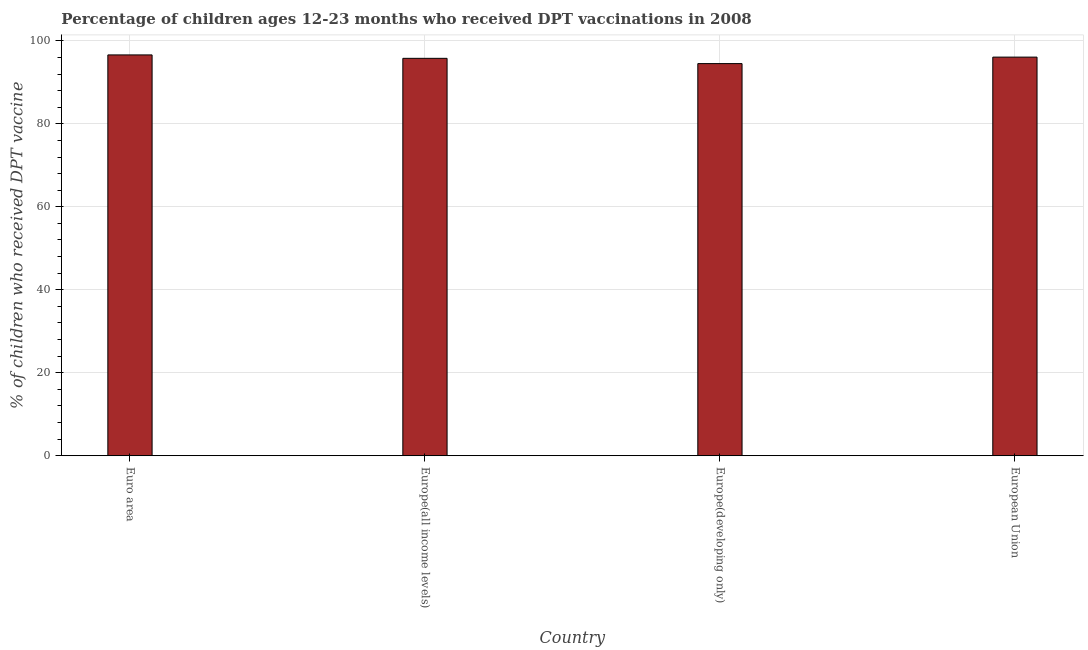Does the graph contain any zero values?
Your answer should be compact. No. What is the title of the graph?
Your response must be concise. Percentage of children ages 12-23 months who received DPT vaccinations in 2008. What is the label or title of the X-axis?
Make the answer very short. Country. What is the label or title of the Y-axis?
Ensure brevity in your answer.  % of children who received DPT vaccine. What is the percentage of children who received dpt vaccine in European Union?
Offer a very short reply. 96.08. Across all countries, what is the maximum percentage of children who received dpt vaccine?
Provide a short and direct response. 96.61. Across all countries, what is the minimum percentage of children who received dpt vaccine?
Keep it short and to the point. 94.52. In which country was the percentage of children who received dpt vaccine minimum?
Provide a short and direct response. Europe(developing only). What is the sum of the percentage of children who received dpt vaccine?
Offer a very short reply. 382.99. What is the difference between the percentage of children who received dpt vaccine in Euro area and Europe(developing only)?
Ensure brevity in your answer.  2.09. What is the average percentage of children who received dpt vaccine per country?
Offer a terse response. 95.75. What is the median percentage of children who received dpt vaccine?
Give a very brief answer. 95.93. What is the difference between the highest and the second highest percentage of children who received dpt vaccine?
Keep it short and to the point. 0.53. What is the difference between the highest and the lowest percentage of children who received dpt vaccine?
Keep it short and to the point. 2.09. What is the % of children who received DPT vaccine of Euro area?
Ensure brevity in your answer.  96.61. What is the % of children who received DPT vaccine in Europe(all income levels)?
Your response must be concise. 95.78. What is the % of children who received DPT vaccine in Europe(developing only)?
Offer a terse response. 94.52. What is the % of children who received DPT vaccine of European Union?
Ensure brevity in your answer.  96.08. What is the difference between the % of children who received DPT vaccine in Euro area and Europe(all income levels)?
Give a very brief answer. 0.82. What is the difference between the % of children who received DPT vaccine in Euro area and Europe(developing only)?
Give a very brief answer. 2.09. What is the difference between the % of children who received DPT vaccine in Euro area and European Union?
Provide a short and direct response. 0.53. What is the difference between the % of children who received DPT vaccine in Europe(all income levels) and Europe(developing only)?
Ensure brevity in your answer.  1.27. What is the difference between the % of children who received DPT vaccine in Europe(all income levels) and European Union?
Your answer should be very brief. -0.29. What is the difference between the % of children who received DPT vaccine in Europe(developing only) and European Union?
Give a very brief answer. -1.56. What is the ratio of the % of children who received DPT vaccine in Euro area to that in Europe(all income levels)?
Make the answer very short. 1.01. What is the ratio of the % of children who received DPT vaccine in Euro area to that in Europe(developing only)?
Make the answer very short. 1.02. What is the ratio of the % of children who received DPT vaccine in Euro area to that in European Union?
Your answer should be compact. 1.01. What is the ratio of the % of children who received DPT vaccine in Europe(all income levels) to that in Europe(developing only)?
Your answer should be compact. 1.01. 